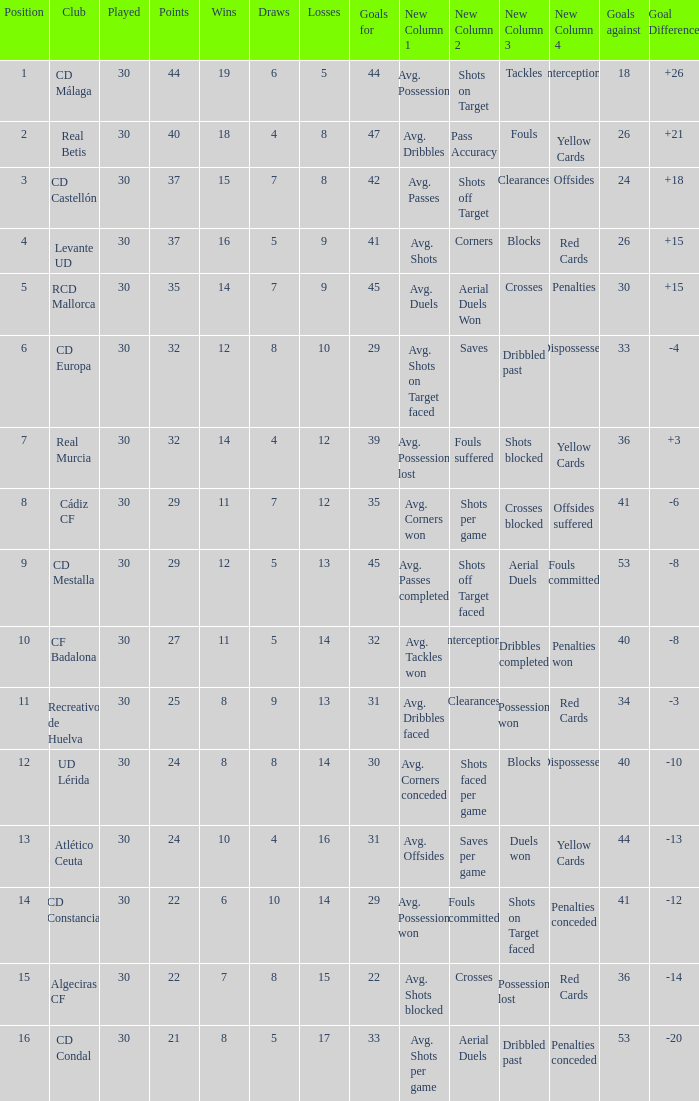What is the number of losses when the goal difference was -8, and position is smaller than 10? 1.0. 